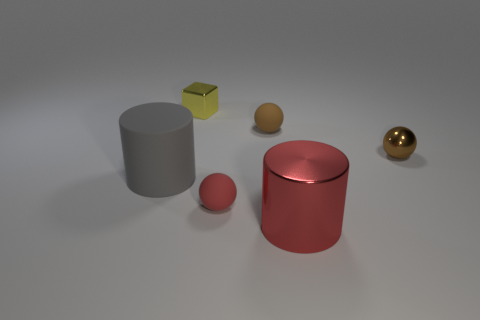There is a thing that is both to the left of the red matte ball and right of the big rubber cylinder; what is its size?
Make the answer very short. Small. How many brown matte balls are the same size as the gray rubber object?
Your response must be concise. 0. What size is the brown thing that is right of the large red metallic object on the right side of the red matte thing?
Provide a succinct answer. Small. Does the big object behind the red matte sphere have the same shape as the metal object that is to the left of the large red metal cylinder?
Your response must be concise. No. What is the color of the metallic thing that is behind the small red sphere and in front of the block?
Keep it short and to the point. Brown. Are there any shiny things of the same color as the big metallic cylinder?
Keep it short and to the point. No. The big thing right of the red sphere is what color?
Provide a succinct answer. Red. Are there any brown objects that are in front of the large cylinder that is in front of the gray thing?
Give a very brief answer. No. Does the shiny cube have the same color as the cylinder that is to the left of the brown matte object?
Ensure brevity in your answer.  No. Is there another gray cube that has the same material as the cube?
Give a very brief answer. No. 